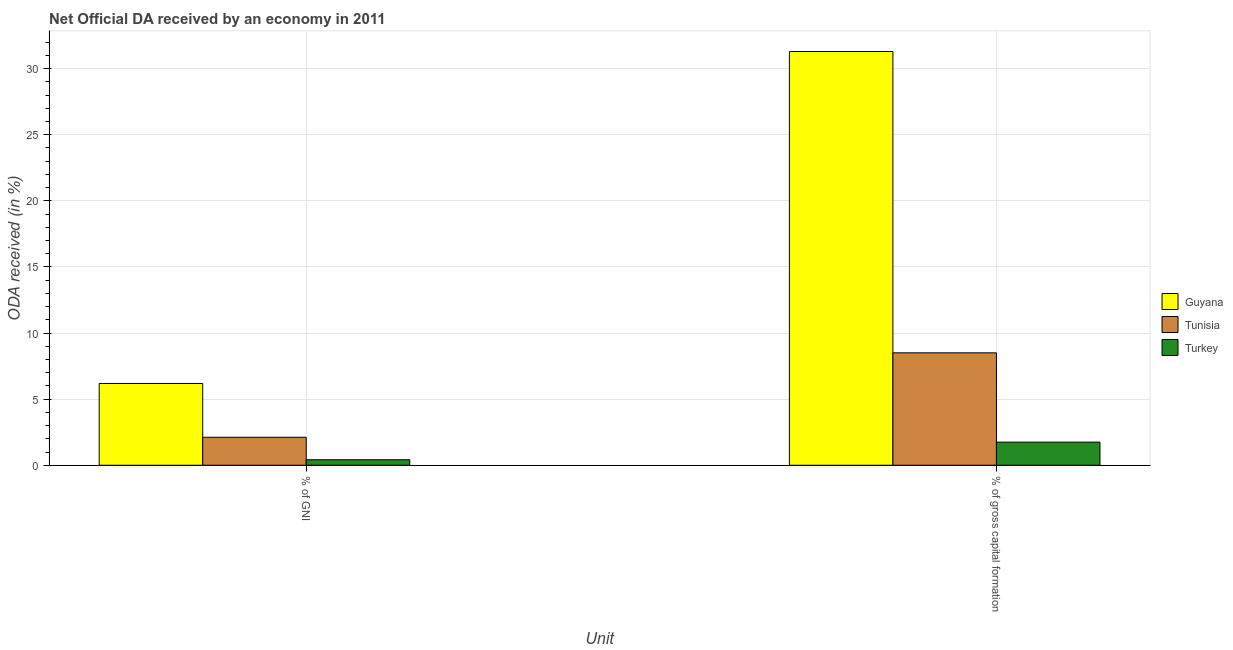How many different coloured bars are there?
Offer a terse response. 3. Are the number of bars per tick equal to the number of legend labels?
Keep it short and to the point. Yes. Are the number of bars on each tick of the X-axis equal?
Your response must be concise. Yes. What is the label of the 1st group of bars from the left?
Keep it short and to the point. % of GNI. What is the oda received as percentage of gross capital formation in Guyana?
Offer a terse response. 31.29. Across all countries, what is the maximum oda received as percentage of gni?
Give a very brief answer. 6.18. Across all countries, what is the minimum oda received as percentage of gni?
Make the answer very short. 0.42. In which country was the oda received as percentage of gross capital formation maximum?
Your answer should be compact. Guyana. In which country was the oda received as percentage of gross capital formation minimum?
Provide a succinct answer. Turkey. What is the total oda received as percentage of gross capital formation in the graph?
Give a very brief answer. 41.54. What is the difference between the oda received as percentage of gni in Turkey and that in Guyana?
Offer a very short reply. -5.77. What is the difference between the oda received as percentage of gni in Turkey and the oda received as percentage of gross capital formation in Tunisia?
Offer a terse response. -8.08. What is the average oda received as percentage of gross capital formation per country?
Your answer should be compact. 13.85. What is the difference between the oda received as percentage of gni and oda received as percentage of gross capital formation in Turkey?
Your response must be concise. -1.33. In how many countries, is the oda received as percentage of gross capital formation greater than 12 %?
Provide a succinct answer. 1. What is the ratio of the oda received as percentage of gni in Guyana to that in Turkey?
Ensure brevity in your answer.  14.87. In how many countries, is the oda received as percentage of gni greater than the average oda received as percentage of gni taken over all countries?
Your answer should be compact. 1. What does the 2nd bar from the left in % of gross capital formation represents?
Make the answer very short. Tunisia. How many countries are there in the graph?
Your answer should be very brief. 3. What is the difference between two consecutive major ticks on the Y-axis?
Provide a short and direct response. 5. Does the graph contain any zero values?
Your response must be concise. No. Where does the legend appear in the graph?
Your response must be concise. Center right. How many legend labels are there?
Offer a terse response. 3. How are the legend labels stacked?
Your response must be concise. Vertical. What is the title of the graph?
Ensure brevity in your answer.  Net Official DA received by an economy in 2011. What is the label or title of the X-axis?
Provide a succinct answer. Unit. What is the label or title of the Y-axis?
Provide a succinct answer. ODA received (in %). What is the ODA received (in %) of Guyana in % of GNI?
Make the answer very short. 6.18. What is the ODA received (in %) of Tunisia in % of GNI?
Make the answer very short. 2.11. What is the ODA received (in %) of Turkey in % of GNI?
Give a very brief answer. 0.42. What is the ODA received (in %) in Guyana in % of gross capital formation?
Give a very brief answer. 31.29. What is the ODA received (in %) in Tunisia in % of gross capital formation?
Your answer should be compact. 8.5. What is the ODA received (in %) in Turkey in % of gross capital formation?
Your response must be concise. 1.75. Across all Unit, what is the maximum ODA received (in %) in Guyana?
Provide a succinct answer. 31.29. Across all Unit, what is the maximum ODA received (in %) of Tunisia?
Make the answer very short. 8.5. Across all Unit, what is the maximum ODA received (in %) in Turkey?
Provide a succinct answer. 1.75. Across all Unit, what is the minimum ODA received (in %) of Guyana?
Keep it short and to the point. 6.18. Across all Unit, what is the minimum ODA received (in %) in Tunisia?
Ensure brevity in your answer.  2.11. Across all Unit, what is the minimum ODA received (in %) in Turkey?
Offer a very short reply. 0.42. What is the total ODA received (in %) in Guyana in the graph?
Your answer should be very brief. 37.47. What is the total ODA received (in %) in Tunisia in the graph?
Your answer should be compact. 10.62. What is the total ODA received (in %) of Turkey in the graph?
Your response must be concise. 2.16. What is the difference between the ODA received (in %) of Guyana in % of GNI and that in % of gross capital formation?
Your answer should be very brief. -25.11. What is the difference between the ODA received (in %) in Tunisia in % of GNI and that in % of gross capital formation?
Your answer should be very brief. -6.39. What is the difference between the ODA received (in %) in Turkey in % of GNI and that in % of gross capital formation?
Your answer should be compact. -1.33. What is the difference between the ODA received (in %) of Guyana in % of GNI and the ODA received (in %) of Tunisia in % of gross capital formation?
Make the answer very short. -2.32. What is the difference between the ODA received (in %) in Guyana in % of GNI and the ODA received (in %) in Turkey in % of gross capital formation?
Give a very brief answer. 4.44. What is the difference between the ODA received (in %) in Tunisia in % of GNI and the ODA received (in %) in Turkey in % of gross capital formation?
Ensure brevity in your answer.  0.37. What is the average ODA received (in %) of Guyana per Unit?
Make the answer very short. 18.74. What is the average ODA received (in %) of Tunisia per Unit?
Ensure brevity in your answer.  5.31. What is the average ODA received (in %) of Turkey per Unit?
Provide a short and direct response. 1.08. What is the difference between the ODA received (in %) in Guyana and ODA received (in %) in Tunisia in % of GNI?
Make the answer very short. 4.07. What is the difference between the ODA received (in %) of Guyana and ODA received (in %) of Turkey in % of GNI?
Your answer should be compact. 5.77. What is the difference between the ODA received (in %) in Tunisia and ODA received (in %) in Turkey in % of GNI?
Make the answer very short. 1.7. What is the difference between the ODA received (in %) of Guyana and ODA received (in %) of Tunisia in % of gross capital formation?
Make the answer very short. 22.79. What is the difference between the ODA received (in %) of Guyana and ODA received (in %) of Turkey in % of gross capital formation?
Make the answer very short. 29.54. What is the difference between the ODA received (in %) of Tunisia and ODA received (in %) of Turkey in % of gross capital formation?
Offer a terse response. 6.75. What is the ratio of the ODA received (in %) in Guyana in % of GNI to that in % of gross capital formation?
Ensure brevity in your answer.  0.2. What is the ratio of the ODA received (in %) of Tunisia in % of GNI to that in % of gross capital formation?
Provide a short and direct response. 0.25. What is the ratio of the ODA received (in %) in Turkey in % of GNI to that in % of gross capital formation?
Offer a very short reply. 0.24. What is the difference between the highest and the second highest ODA received (in %) in Guyana?
Keep it short and to the point. 25.11. What is the difference between the highest and the second highest ODA received (in %) of Tunisia?
Keep it short and to the point. 6.39. What is the difference between the highest and the second highest ODA received (in %) in Turkey?
Offer a terse response. 1.33. What is the difference between the highest and the lowest ODA received (in %) of Guyana?
Give a very brief answer. 25.11. What is the difference between the highest and the lowest ODA received (in %) of Tunisia?
Your answer should be compact. 6.39. What is the difference between the highest and the lowest ODA received (in %) of Turkey?
Ensure brevity in your answer.  1.33. 